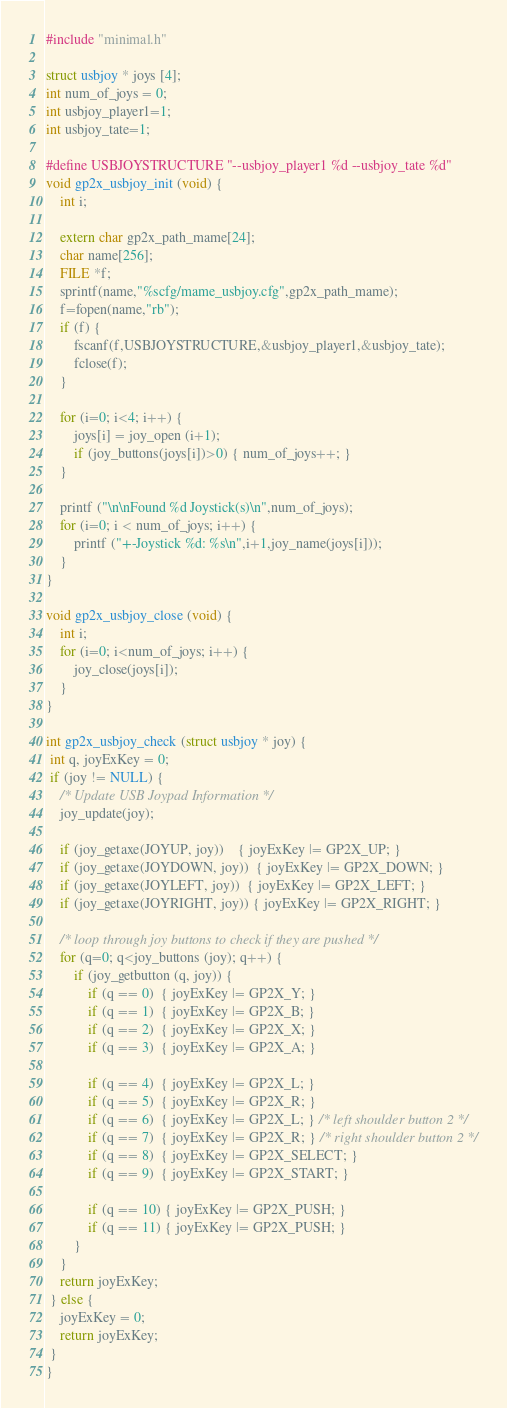Convert code to text. <code><loc_0><loc_0><loc_500><loc_500><_C++_>
#include "minimal.h"

struct usbjoy * joys [4];
int num_of_joys = 0;
int usbjoy_player1=1;
int usbjoy_tate=1;

#define USBJOYSTRUCTURE "--usbjoy_player1 %d --usbjoy_tate %d"
void gp2x_usbjoy_init (void) {
	int i;

	extern char gp2x_path_mame[24];
	char name[256];
	FILE *f;
	sprintf(name,"%scfg/mame_usbjoy.cfg",gp2x_path_mame);
	f=fopen(name,"rb");
	if (f) {
		fscanf(f,USBJOYSTRUCTURE,&usbjoy_player1,&usbjoy_tate);
		fclose(f);
	}
		
	for (i=0; i<4; i++) {
		joys[i] = joy_open (i+1);
		if (joy_buttons(joys[i])>0) { num_of_joys++; }
	}

	printf ("\n\nFound %d Joystick(s)\n",num_of_joys);
	for (i=0; i < num_of_joys; i++) {
		printf ("+-Joystick %d: %s\n",i+1,joy_name(joys[i]));
	}
}

void gp2x_usbjoy_close (void) {
	int i;
	for (i=0; i<num_of_joys; i++) {
		joy_close(joys[i]);
	}
}

int gp2x_usbjoy_check (struct usbjoy * joy) {
 int q, joyExKey = 0;
 if (joy != NULL) {
	/* Update USB Joypad Information */
	joy_update(joy);
	
	if (joy_getaxe(JOYUP, joy))    { joyExKey |= GP2X_UP; }
	if (joy_getaxe(JOYDOWN, joy))  { joyExKey |= GP2X_DOWN; }
	if (joy_getaxe(JOYLEFT, joy))  { joyExKey |= GP2X_LEFT; }
	if (joy_getaxe(JOYRIGHT, joy)) { joyExKey |= GP2X_RIGHT; }

	/* loop through joy buttons to check if they are pushed */
	for (q=0; q<joy_buttons (joy); q++) {
		if (joy_getbutton (q, joy)) {
			if (q == 0)  { joyExKey |= GP2X_Y; }
			if (q == 1)  { joyExKey |= GP2X_B; }
			if (q == 2)  { joyExKey |= GP2X_X; }
			if (q == 3)  { joyExKey |= GP2X_A; }

			if (q == 4)  { joyExKey |= GP2X_L; }
			if (q == 5)  { joyExKey |= GP2X_R; }
			if (q == 6)  { joyExKey |= GP2X_L; } /* left shoulder button 2 */
			if (q == 7)  { joyExKey |= GP2X_R; } /* right shoulder button 2 */
			if (q == 8)  { joyExKey |= GP2X_SELECT; }
			if (q == 9)  { joyExKey |= GP2X_START; }

			if (q == 10) { joyExKey |= GP2X_PUSH; }
			if (q == 11) { joyExKey |= GP2X_PUSH; }
		}
	}
	return joyExKey;
 } else {
	joyExKey = 0;
	return joyExKey;
 }
}
</code> 